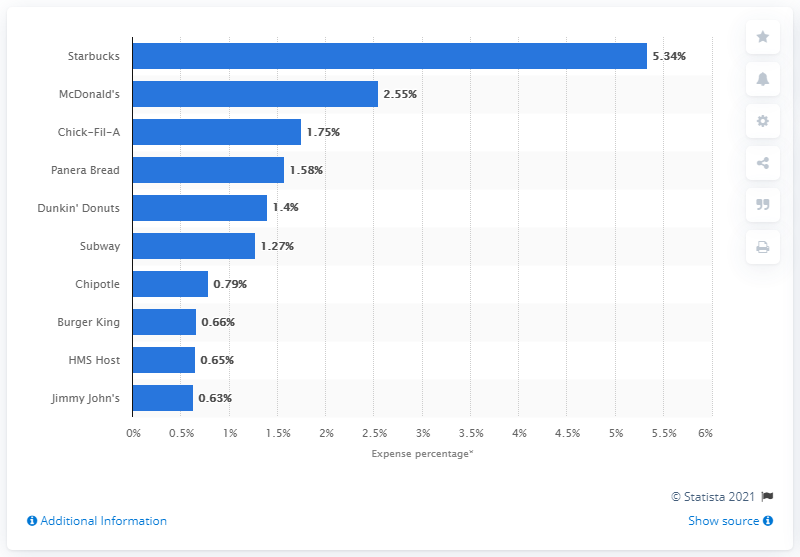Highlight a few significant elements in this photo. According to data collected in the second quarter of 2019, Starbucks was the restaurant that was most frequently expensed by business travelers. 